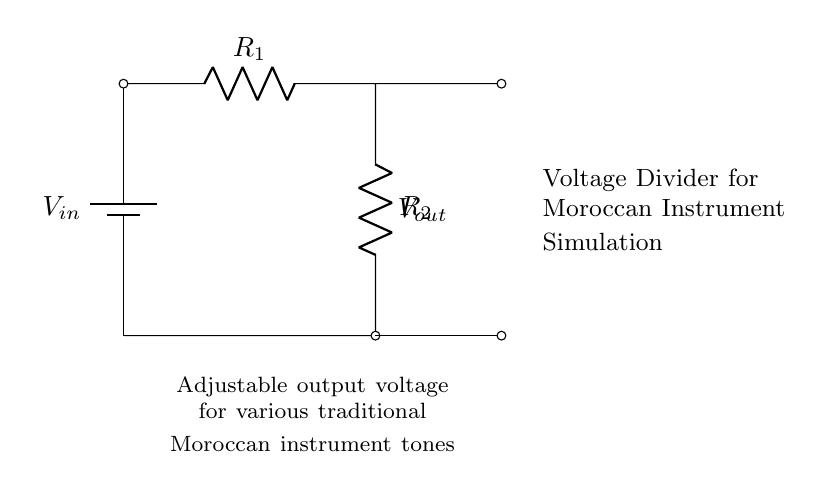What is the input voltage of the circuit? The circuit diagram indicates the input voltage as V_in connected to the battery symbol at the top left of the circuit. The exact numerical value isn't provided, but it's labeled as V_in.
Answer: V_in What are the two resistors labeled in the circuit? The diagram shows two resistors, R_1 and R_2, connected in series. They are represented by "R=" annotations next to each component.
Answer: R_1 and R_2 What type of circuit is represented by this diagram? The configuration and function of the components indicate that this is a voltage divider circuit. Voltage dividers are specifically designed to produce an output voltage that is a fraction of the input voltage.
Answer: Voltage divider What does V_out represent in the circuit? V_out is labeled at the junction between the two resistors, indicating the output voltage that can be adjusted based on the values of R_1 and R_2. This is a key feature of voltage dividers where the output voltage can be varied.
Answer: Output voltage How does adjusting R_1 or R_2 affect V_out? Changing the values of R_1 or R_2 alters the voltage division ratio, leading to a different output voltage, V_out. The output voltage is directly influenced by the resistance values relative to each other according to the voltage divider formula.
Answer: It changes V_out What is the primary use of this voltage divider circuit in the context provided? The circuit is specifically designed for simulating the output tones of traditional Moroccan musical instruments, indicating its application in creating various sound simulations.
Answer: Simulating instrument tones 